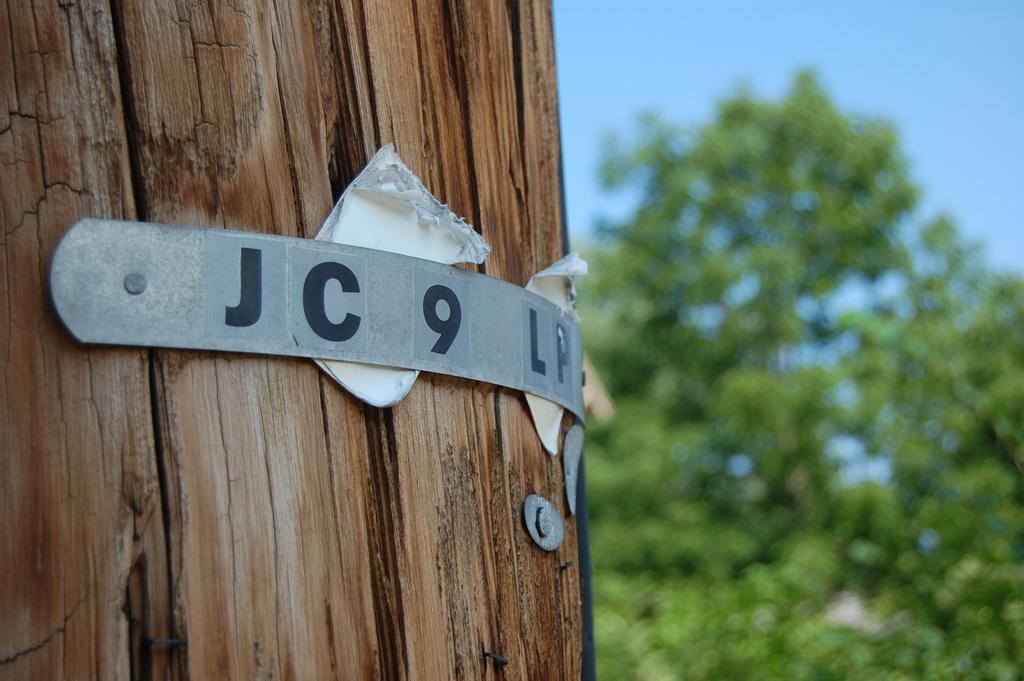Please provide a concise description of this image. On the left side of this image I can see a trunk to which a metal board and some papers are attached. In the background there is a tree. On the top of the image I can see the sky. 